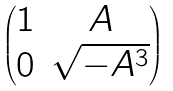Convert formula to latex. <formula><loc_0><loc_0><loc_500><loc_500>\begin{pmatrix} 1 & A \\ 0 & \sqrt { - A ^ { 3 } } \end{pmatrix}</formula> 